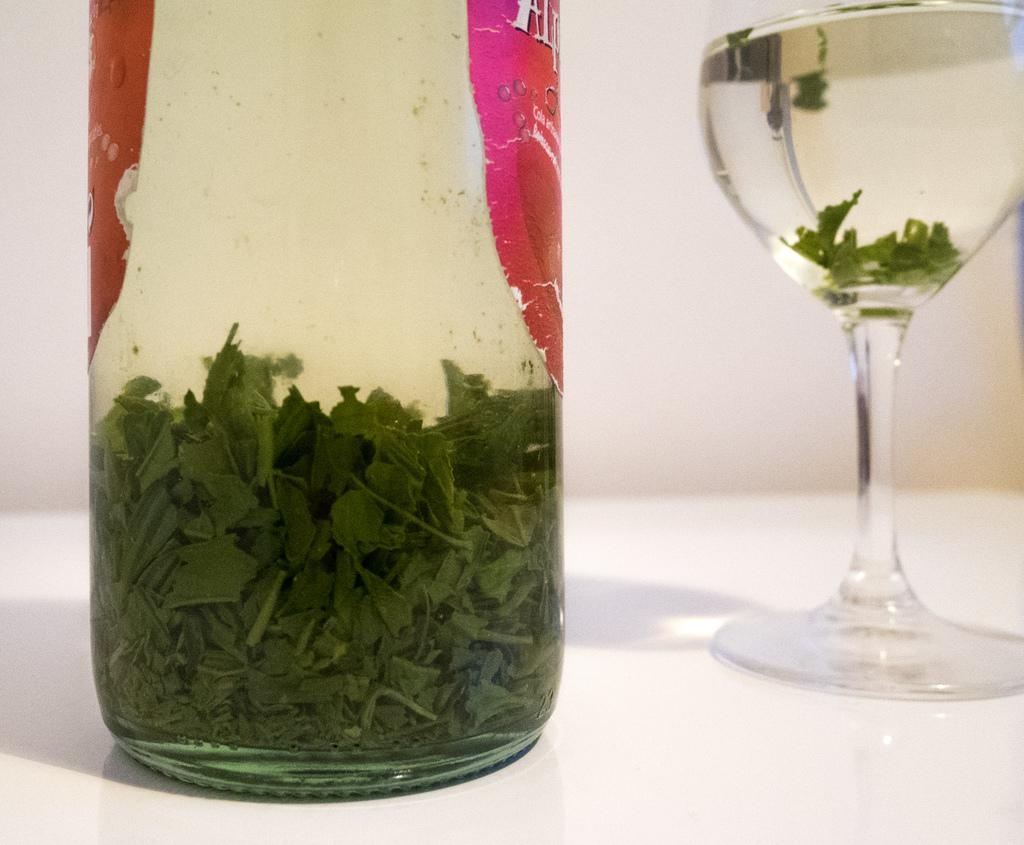What is in the bottle that is visible in the image? The bottle contains a drink. What is in the glass that is visible in the image? The glass contains a drink. Where are the bottle and glass located in the image? The bottle and glass are placed on a table. What type of insect can be seen crawling on the underwear in the image? There is no insect or underwear present in the image; it only features a bottle and a glass on a table. 